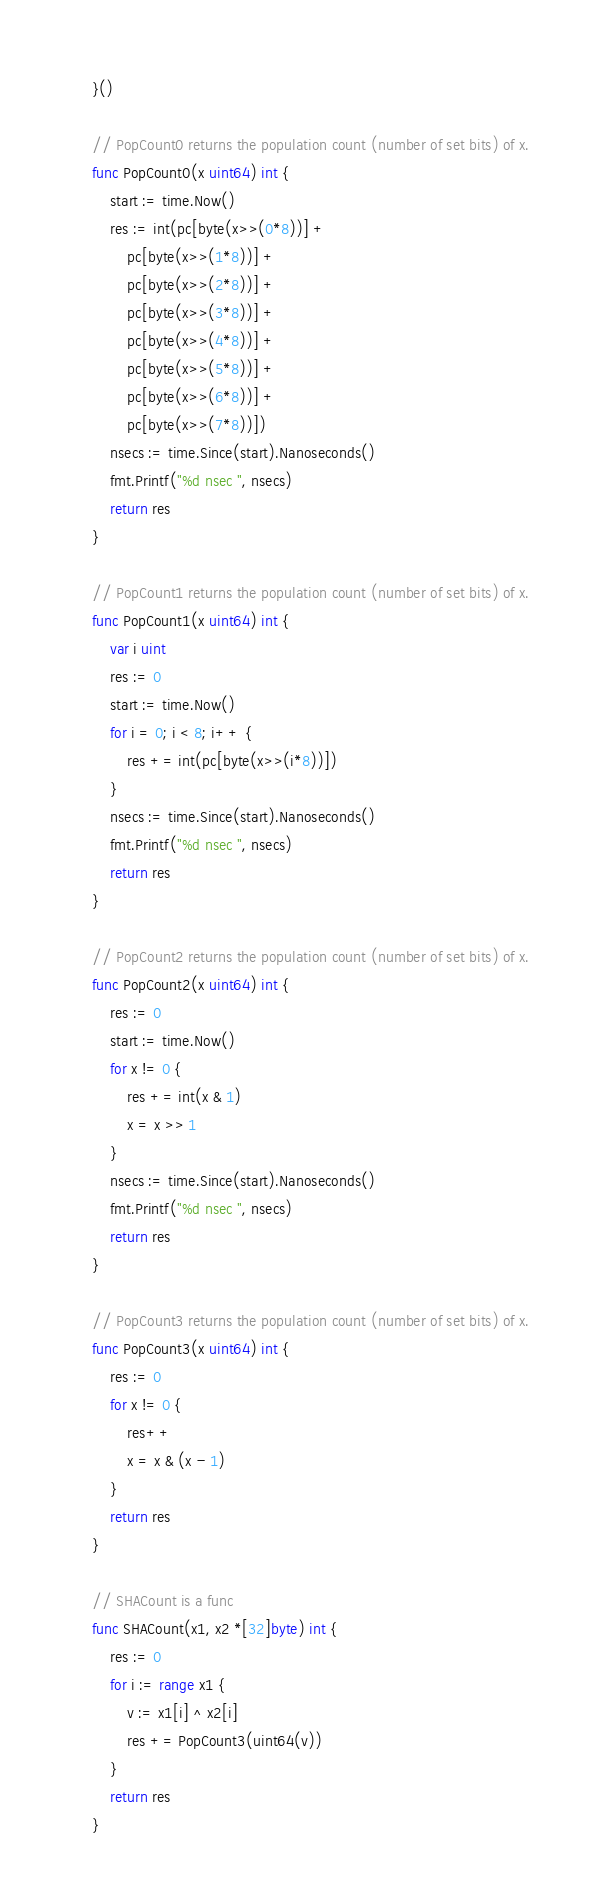<code> <loc_0><loc_0><loc_500><loc_500><_Go_>}()

// PopCount0 returns the population count (number of set bits) of x.
func PopCount0(x uint64) int {
	start := time.Now()
	res := int(pc[byte(x>>(0*8))] +
		pc[byte(x>>(1*8))] +
		pc[byte(x>>(2*8))] +
		pc[byte(x>>(3*8))] +
		pc[byte(x>>(4*8))] +
		pc[byte(x>>(5*8))] +
		pc[byte(x>>(6*8))] +
		pc[byte(x>>(7*8))])
	nsecs := time.Since(start).Nanoseconds()
	fmt.Printf("%d nsec ", nsecs)
	return res
}

// PopCount1 returns the population count (number of set bits) of x.
func PopCount1(x uint64) int {
	var i uint
	res := 0
	start := time.Now()
	for i = 0; i < 8; i++ {
		res += int(pc[byte(x>>(i*8))])
	}
	nsecs := time.Since(start).Nanoseconds()
	fmt.Printf("%d nsec ", nsecs)
	return res
}

// PopCount2 returns the population count (number of set bits) of x.
func PopCount2(x uint64) int {
	res := 0
	start := time.Now()
	for x != 0 {
		res += int(x & 1)
		x = x >> 1
	}
	nsecs := time.Since(start).Nanoseconds()
	fmt.Printf("%d nsec ", nsecs)
	return res
}

// PopCount3 returns the population count (number of set bits) of x.
func PopCount3(x uint64) int {
	res := 0
	for x != 0 {
		res++
		x = x & (x - 1)
	}
	return res
}

// SHACount is a func
func SHACount(x1, x2 *[32]byte) int {
	res := 0
	for i := range x1 {
		v := x1[i] ^ x2[i]
		res += PopCount3(uint64(v))
	}
	return res
}
</code> 